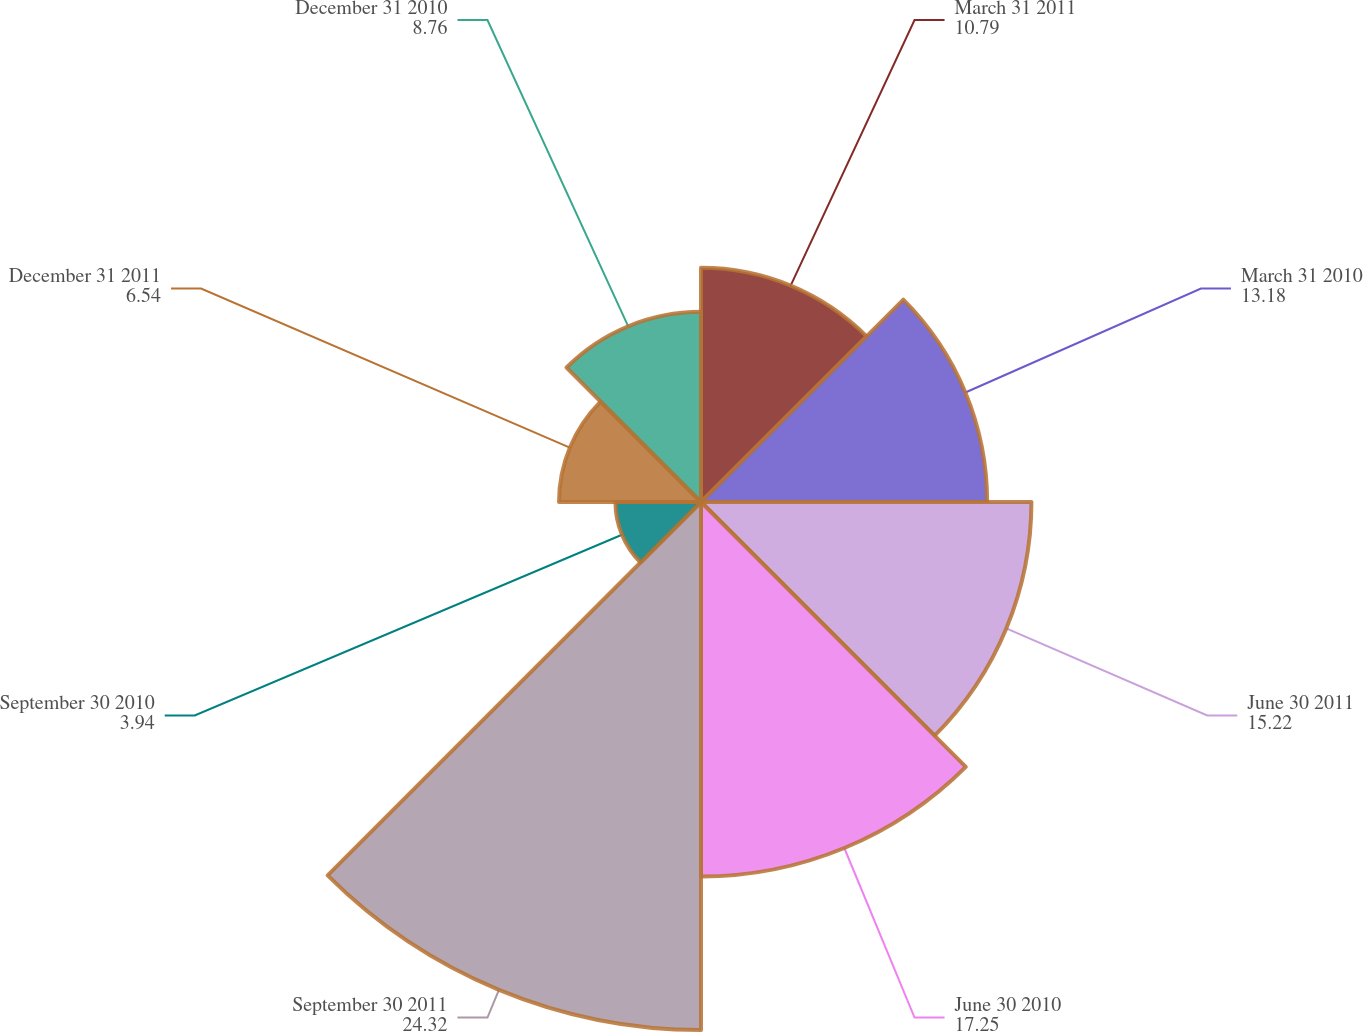Convert chart. <chart><loc_0><loc_0><loc_500><loc_500><pie_chart><fcel>March 31 2011<fcel>March 31 2010<fcel>June 30 2011<fcel>June 30 2010<fcel>September 30 2011<fcel>September 30 2010<fcel>December 31 2011<fcel>December 31 2010<nl><fcel>10.79%<fcel>13.18%<fcel>15.22%<fcel>17.25%<fcel>24.32%<fcel>3.94%<fcel>6.54%<fcel>8.76%<nl></chart> 